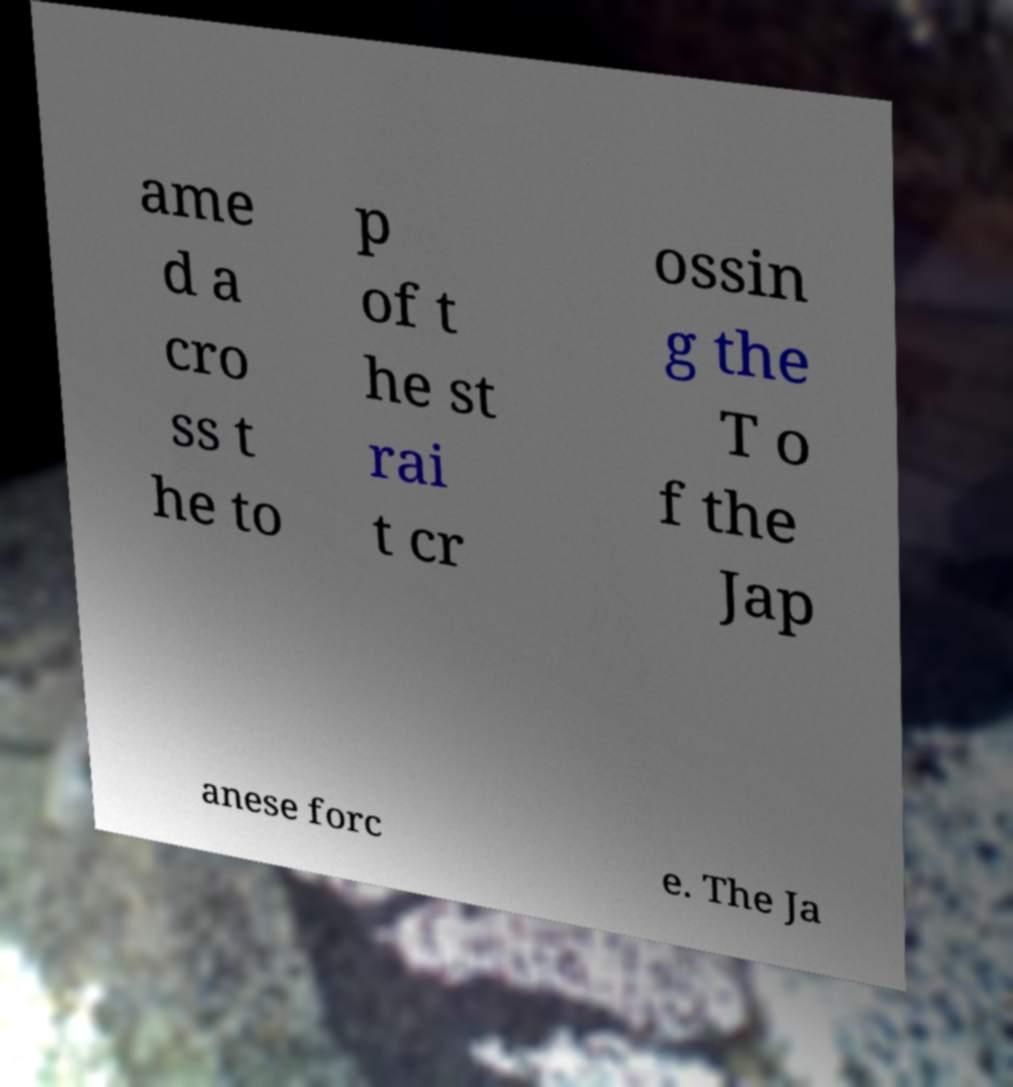There's text embedded in this image that I need extracted. Can you transcribe it verbatim? ame d a cro ss t he to p of t he st rai t cr ossin g the T o f the Jap anese forc e. The Ja 